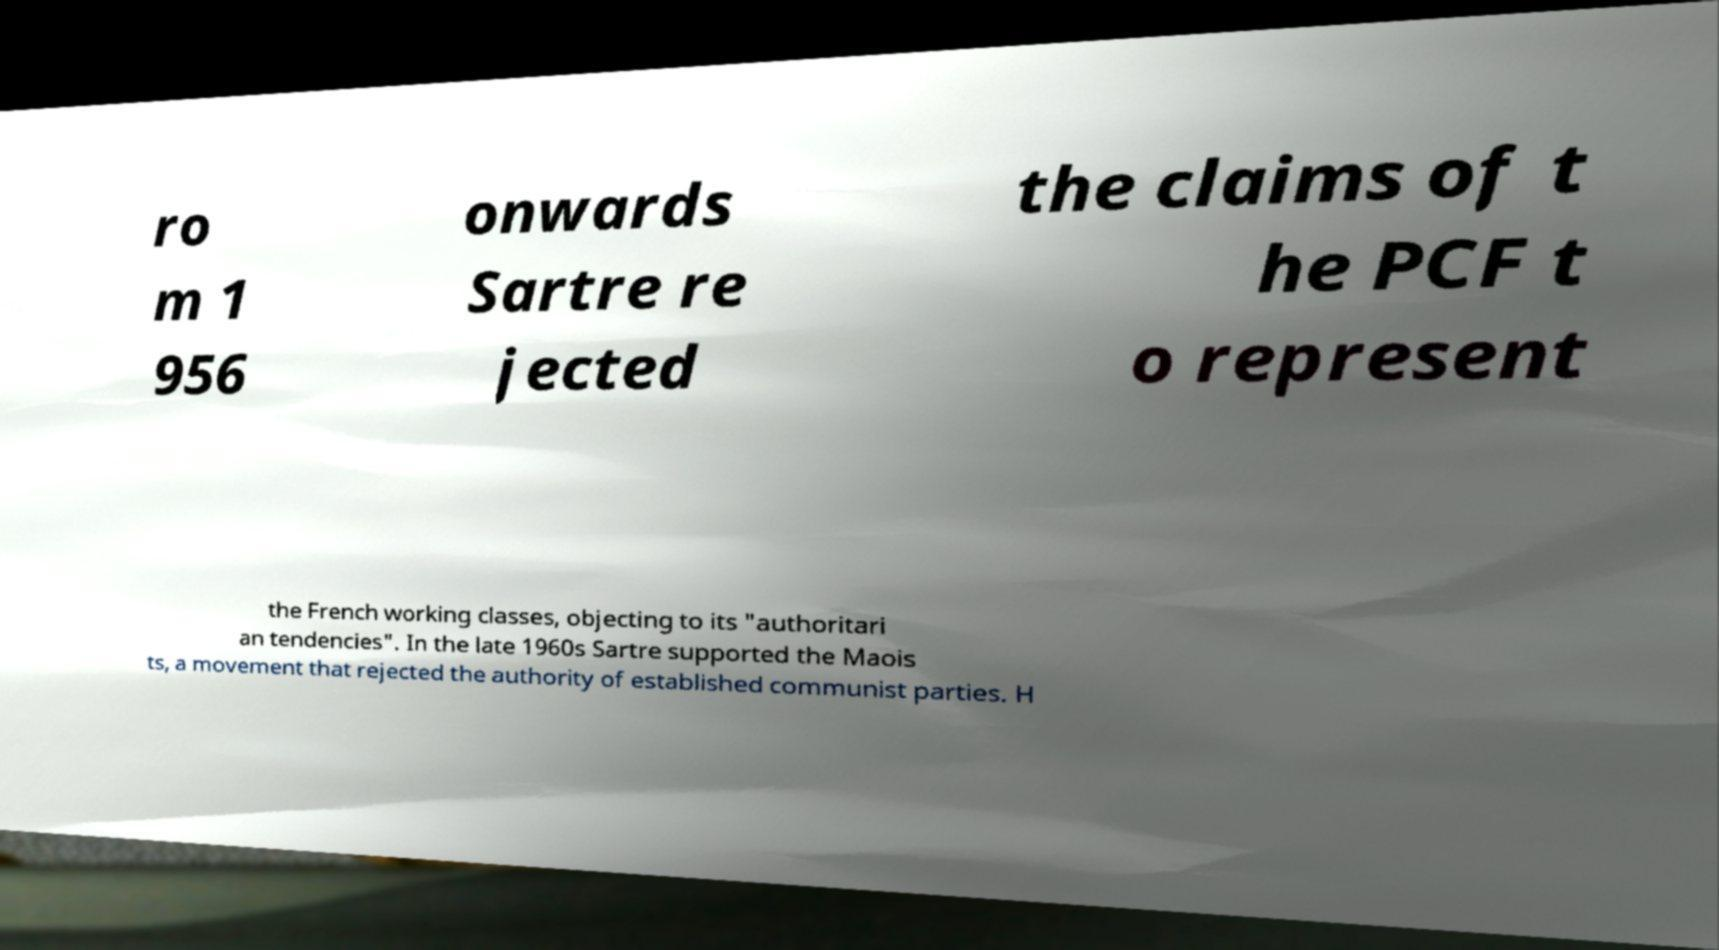Could you extract and type out the text from this image? ro m 1 956 onwards Sartre re jected the claims of t he PCF t o represent the French working classes, objecting to its "authoritari an tendencies". In the late 1960s Sartre supported the Maois ts, a movement that rejected the authority of established communist parties. H 